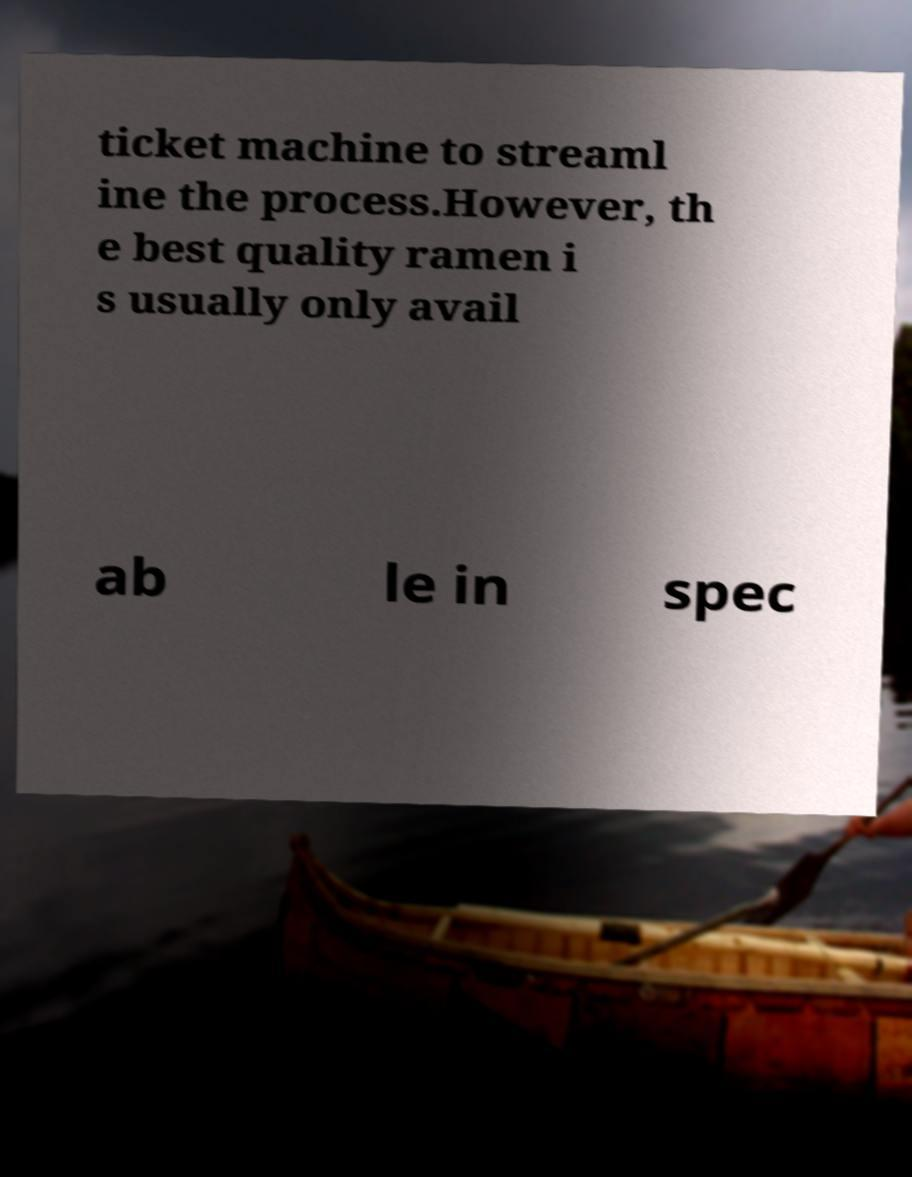What messages or text are displayed in this image? I need them in a readable, typed format. ticket machine to streaml ine the process.However, th e best quality ramen i s usually only avail ab le in spec 